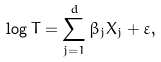<formula> <loc_0><loc_0><loc_500><loc_500>\log T = \sum _ { j = 1 } ^ { d } \beta _ { j } X _ { j } + \varepsilon ,</formula> 